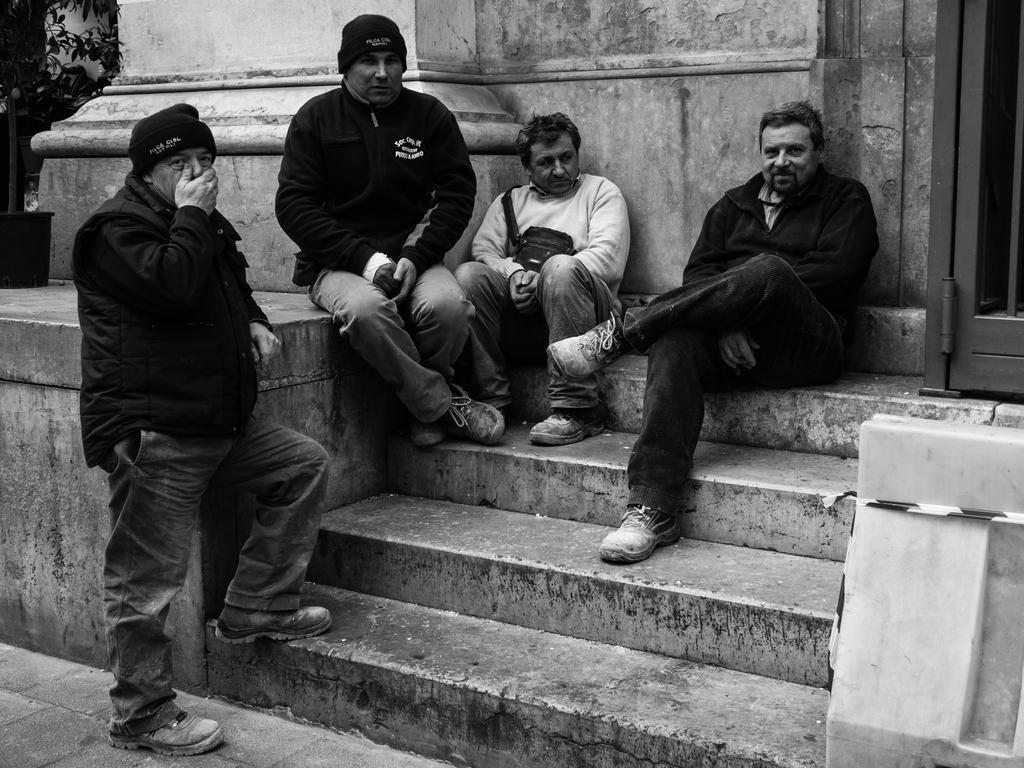How many people are in the image? There are four men in the image. What are the positions of the men in the image? Three of the men are sitting, and one of the men is standing. Where are the men located in the image? They are on the land. What can be seen in the background of the image? There is a wall in the background of the image. What is the color scheme of the image? The image is black and white. Can you see a kitten playing with a coach in the image? No, there is no kitten or coach present in the image. What type of marble is being used to create the wall in the background? There is no marble visible in the image; it only features a wall in the background. 